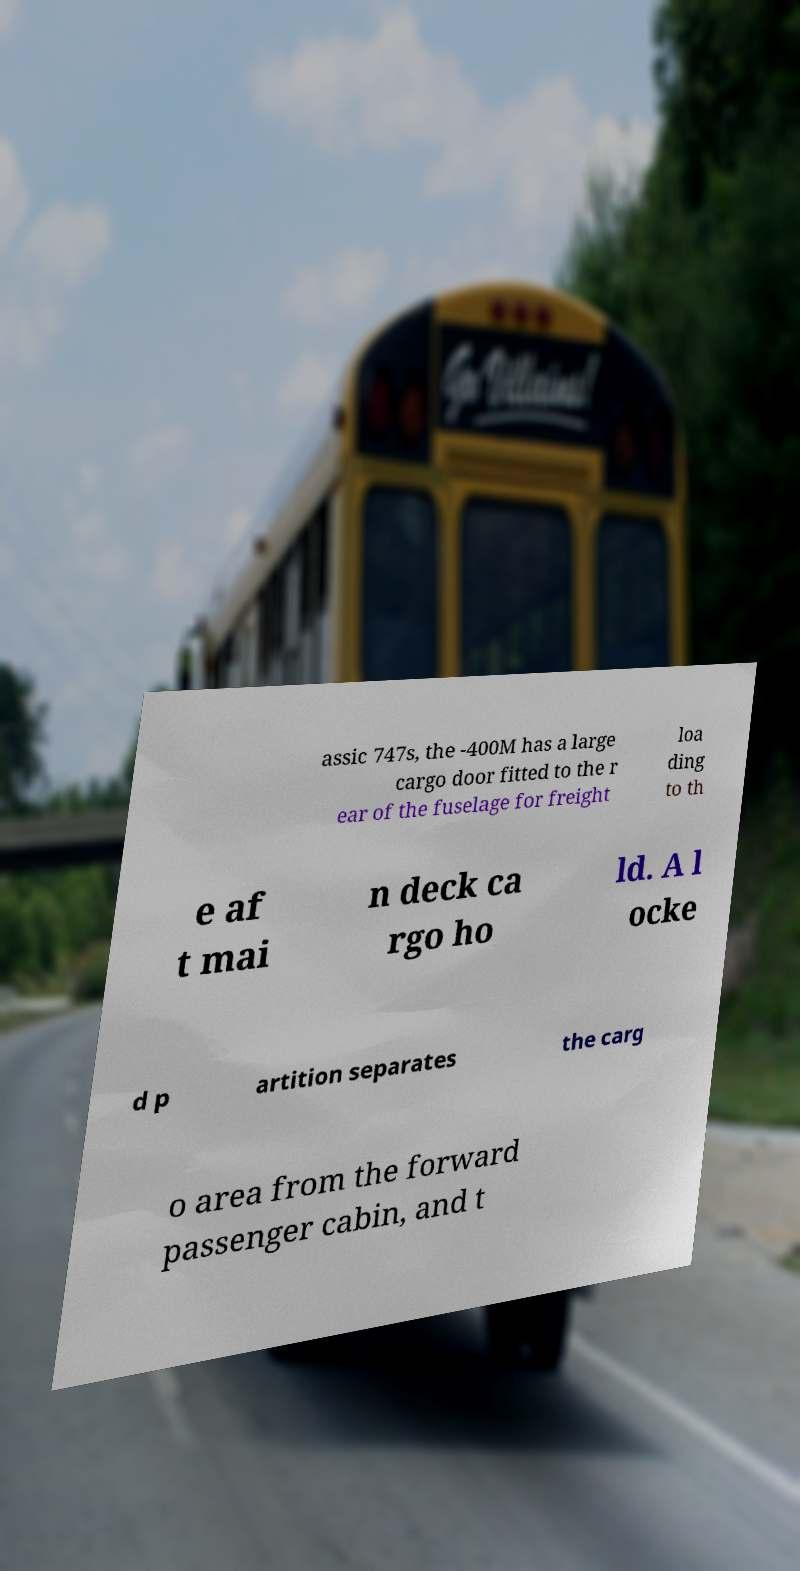What messages or text are displayed in this image? I need them in a readable, typed format. assic 747s, the -400M has a large cargo door fitted to the r ear of the fuselage for freight loa ding to th e af t mai n deck ca rgo ho ld. A l ocke d p artition separates the carg o area from the forward passenger cabin, and t 